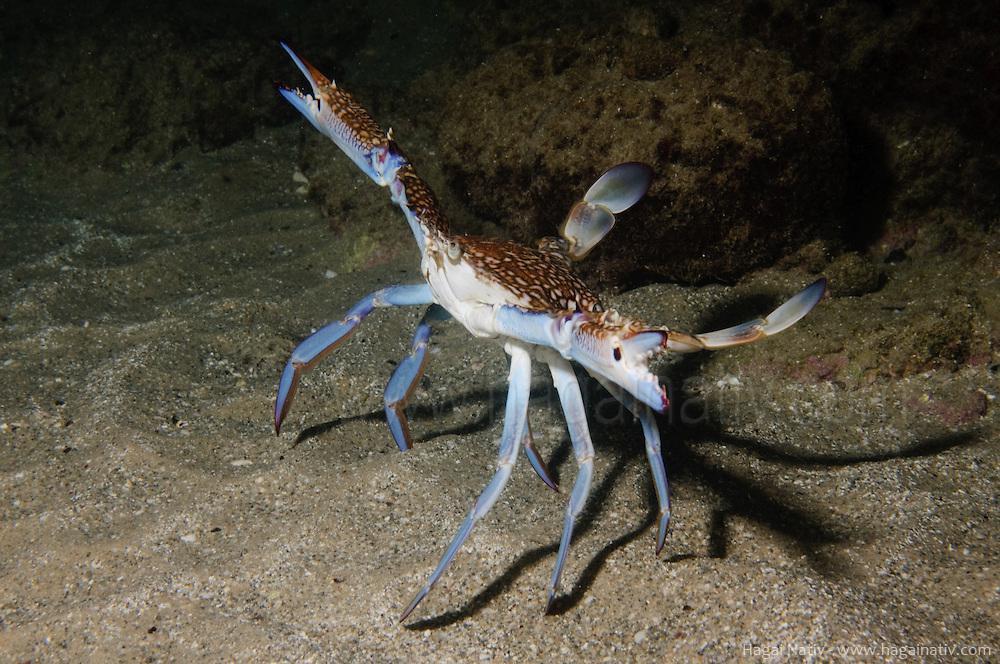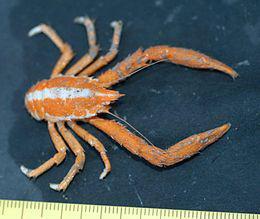The first image is the image on the left, the second image is the image on the right. For the images displayed, is the sentence "In at least one image there is a blue crab in the water touching sand." factually correct? Answer yes or no. Yes. The first image is the image on the left, the second image is the image on the right. For the images shown, is this caption "One crab is standing up tall on the sand." true? Answer yes or no. Yes. 